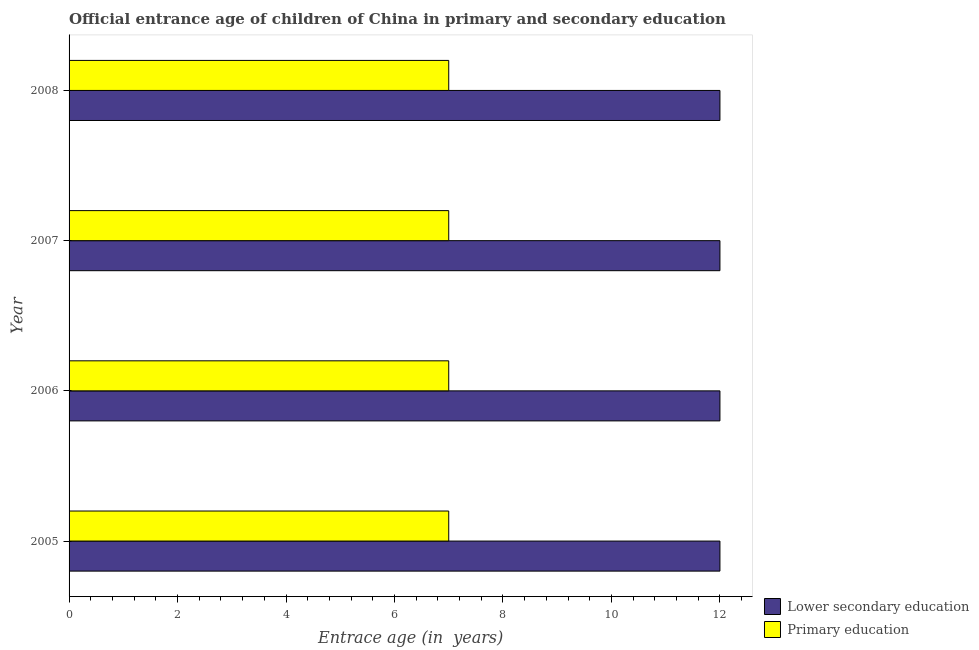How many different coloured bars are there?
Offer a very short reply. 2. Are the number of bars per tick equal to the number of legend labels?
Your response must be concise. Yes. Are the number of bars on each tick of the Y-axis equal?
Keep it short and to the point. Yes. How many bars are there on the 4th tick from the top?
Your answer should be very brief. 2. How many bars are there on the 2nd tick from the bottom?
Your answer should be compact. 2. In how many cases, is the number of bars for a given year not equal to the number of legend labels?
Your answer should be compact. 0. What is the entrance age of children in lower secondary education in 2005?
Your response must be concise. 12. Across all years, what is the maximum entrance age of chiildren in primary education?
Provide a succinct answer. 7. Across all years, what is the minimum entrance age of chiildren in primary education?
Make the answer very short. 7. In which year was the entrance age of chiildren in primary education maximum?
Your answer should be very brief. 2005. In which year was the entrance age of children in lower secondary education minimum?
Your answer should be compact. 2005. What is the total entrance age of children in lower secondary education in the graph?
Your answer should be very brief. 48. What is the difference between the entrance age of children in lower secondary education in 2006 and the entrance age of chiildren in primary education in 2008?
Ensure brevity in your answer.  5. What is the average entrance age of children in lower secondary education per year?
Give a very brief answer. 12. In the year 2005, what is the difference between the entrance age of chiildren in primary education and entrance age of children in lower secondary education?
Keep it short and to the point. -5. In how many years, is the entrance age of chiildren in primary education greater than 8 years?
Provide a short and direct response. 0. What is the difference between the highest and the second highest entrance age of children in lower secondary education?
Provide a short and direct response. 0. What is the difference between the highest and the lowest entrance age of chiildren in primary education?
Keep it short and to the point. 0. In how many years, is the entrance age of children in lower secondary education greater than the average entrance age of children in lower secondary education taken over all years?
Your response must be concise. 0. What does the 2nd bar from the top in 2008 represents?
Make the answer very short. Lower secondary education. What does the 1st bar from the bottom in 2006 represents?
Offer a terse response. Lower secondary education. Are all the bars in the graph horizontal?
Your answer should be very brief. Yes. How many years are there in the graph?
Provide a succinct answer. 4. What is the difference between two consecutive major ticks on the X-axis?
Provide a short and direct response. 2. Are the values on the major ticks of X-axis written in scientific E-notation?
Offer a terse response. No. Where does the legend appear in the graph?
Keep it short and to the point. Bottom right. What is the title of the graph?
Your answer should be very brief. Official entrance age of children of China in primary and secondary education. Does "Registered firms" appear as one of the legend labels in the graph?
Your answer should be compact. No. What is the label or title of the X-axis?
Your answer should be very brief. Entrace age (in  years). What is the label or title of the Y-axis?
Give a very brief answer. Year. What is the Entrace age (in  years) in Lower secondary education in 2005?
Your answer should be compact. 12. What is the Entrace age (in  years) in Primary education in 2006?
Ensure brevity in your answer.  7. Across all years, what is the maximum Entrace age (in  years) in Lower secondary education?
Offer a very short reply. 12. Across all years, what is the maximum Entrace age (in  years) of Primary education?
Your response must be concise. 7. Across all years, what is the minimum Entrace age (in  years) in Lower secondary education?
Your response must be concise. 12. Across all years, what is the minimum Entrace age (in  years) of Primary education?
Give a very brief answer. 7. What is the total Entrace age (in  years) of Lower secondary education in the graph?
Offer a very short reply. 48. What is the total Entrace age (in  years) in Primary education in the graph?
Offer a very short reply. 28. What is the difference between the Entrace age (in  years) of Primary education in 2005 and that in 2006?
Make the answer very short. 0. What is the difference between the Entrace age (in  years) in Lower secondary education in 2005 and that in 2007?
Give a very brief answer. 0. What is the difference between the Entrace age (in  years) of Primary education in 2005 and that in 2008?
Provide a short and direct response. 0. What is the difference between the Entrace age (in  years) of Lower secondary education in 2006 and that in 2007?
Make the answer very short. 0. What is the difference between the Entrace age (in  years) in Primary education in 2006 and that in 2007?
Your response must be concise. 0. What is the difference between the Entrace age (in  years) of Lower secondary education in 2006 and that in 2008?
Offer a terse response. 0. What is the difference between the Entrace age (in  years) in Primary education in 2007 and that in 2008?
Make the answer very short. 0. What is the difference between the Entrace age (in  years) of Lower secondary education in 2005 and the Entrace age (in  years) of Primary education in 2007?
Ensure brevity in your answer.  5. What is the difference between the Entrace age (in  years) in Lower secondary education in 2006 and the Entrace age (in  years) in Primary education in 2008?
Keep it short and to the point. 5. What is the average Entrace age (in  years) in Lower secondary education per year?
Give a very brief answer. 12. What is the average Entrace age (in  years) in Primary education per year?
Your response must be concise. 7. In the year 2006, what is the difference between the Entrace age (in  years) of Lower secondary education and Entrace age (in  years) of Primary education?
Provide a succinct answer. 5. In the year 2007, what is the difference between the Entrace age (in  years) in Lower secondary education and Entrace age (in  years) in Primary education?
Provide a succinct answer. 5. In the year 2008, what is the difference between the Entrace age (in  years) of Lower secondary education and Entrace age (in  years) of Primary education?
Give a very brief answer. 5. What is the ratio of the Entrace age (in  years) in Lower secondary education in 2005 to that in 2007?
Offer a terse response. 1. What is the ratio of the Entrace age (in  years) of Primary education in 2005 to that in 2007?
Offer a very short reply. 1. What is the ratio of the Entrace age (in  years) in Primary education in 2005 to that in 2008?
Your answer should be compact. 1. What is the ratio of the Entrace age (in  years) in Primary education in 2006 to that in 2007?
Provide a short and direct response. 1. What is the ratio of the Entrace age (in  years) of Lower secondary education in 2006 to that in 2008?
Your answer should be compact. 1. What is the ratio of the Entrace age (in  years) of Primary education in 2006 to that in 2008?
Provide a succinct answer. 1. What is the ratio of the Entrace age (in  years) of Lower secondary education in 2007 to that in 2008?
Offer a terse response. 1. What is the ratio of the Entrace age (in  years) of Primary education in 2007 to that in 2008?
Make the answer very short. 1. What is the difference between the highest and the lowest Entrace age (in  years) in Lower secondary education?
Provide a succinct answer. 0. What is the difference between the highest and the lowest Entrace age (in  years) of Primary education?
Your answer should be compact. 0. 